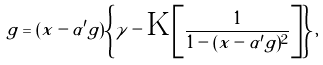<formula> <loc_0><loc_0><loc_500><loc_500>g = ( x - \alpha ^ { \prime } g ) \left \{ \gamma - \text {K} \left [ \frac { 1 } { 1 - ( x - \alpha ^ { \prime } g ) ^ { 2 } } \right ] \right \} ,</formula> 